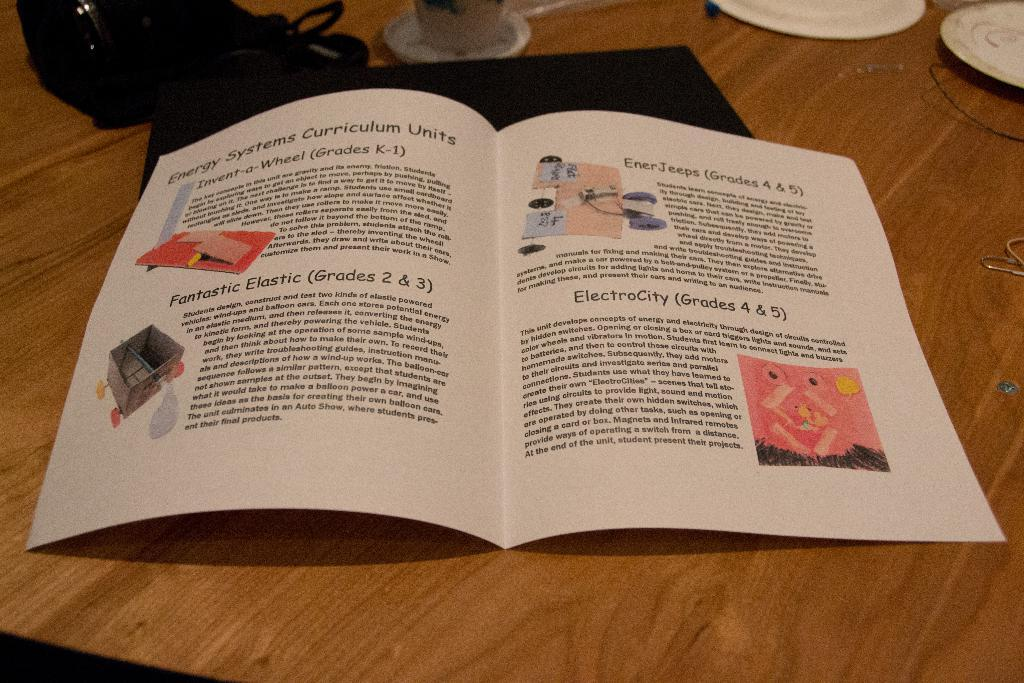<image>
Render a clear and concise summary of the photo. Energy Systems Curriculum Units included Invent-a-Wheel (Grades K-1), Fantastic Elastic (Grades 2 & 3), EnerJeeps (Grades 4 & 5), and ElectroCity (Grades 4 & 5). 